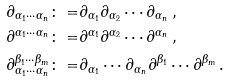Convert formula to latex. <formula><loc_0><loc_0><loc_500><loc_500>\partial _ { \alpha _ { 1 } \cdots \alpha _ { n } } \colon = & \partial _ { \alpha _ { 1 } } \partial _ { \alpha _ { 2 } } \cdots \partial _ { \alpha _ { n } } \, , \\ \partial ^ { \alpha _ { 1 } \cdots \alpha _ { n } } \colon = & \partial ^ { \alpha _ { 1 } } \partial ^ { \alpha _ { 2 } } \cdots \partial ^ { \alpha _ { n } } \, , \\ \partial _ { \alpha _ { 1 } \cdots \alpha _ { n } } ^ { \beta _ { 1 } \cdots \beta _ { m } } \colon = & \partial _ { \alpha _ { 1 } } \cdots \partial _ { \alpha _ { n } } \partial ^ { \beta _ { 1 } } \cdots \partial ^ { \beta _ { m } } \, .</formula> 